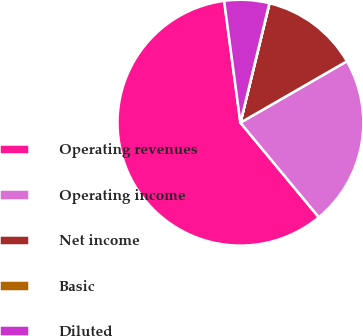<chart> <loc_0><loc_0><loc_500><loc_500><pie_chart><fcel>Operating revenues<fcel>Operating income<fcel>Net income<fcel>Basic<fcel>Diluted<nl><fcel>58.9%<fcel>22.31%<fcel>12.87%<fcel>0.02%<fcel>5.9%<nl></chart> 